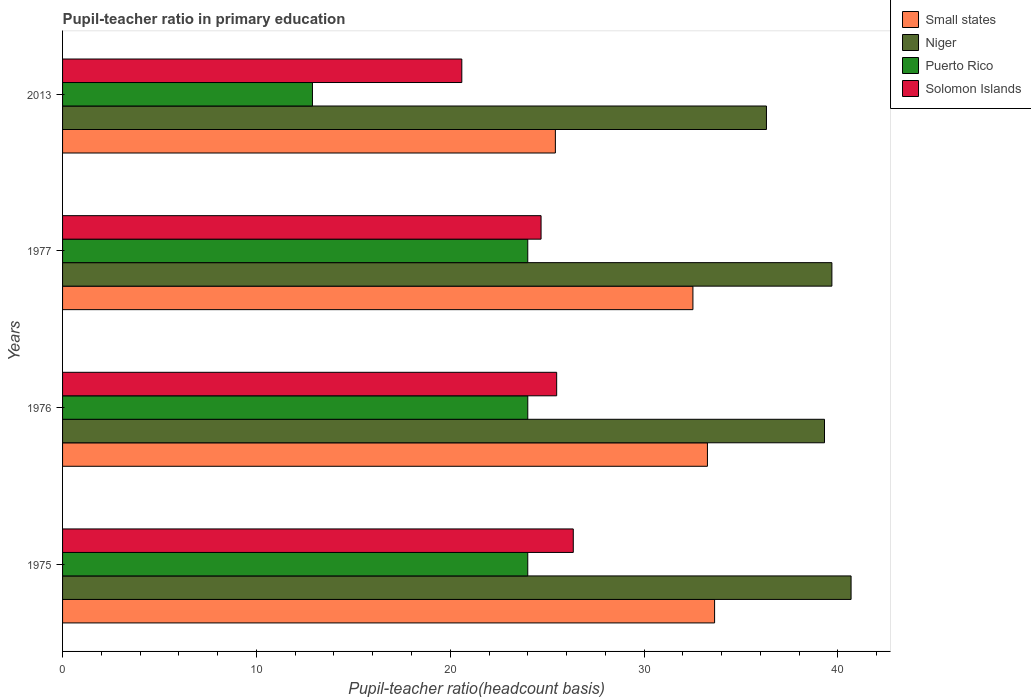What is the label of the 3rd group of bars from the top?
Provide a short and direct response. 1976. What is the pupil-teacher ratio in primary education in Puerto Rico in 1976?
Provide a succinct answer. 24. Across all years, what is the maximum pupil-teacher ratio in primary education in Solomon Islands?
Offer a very short reply. 26.35. Across all years, what is the minimum pupil-teacher ratio in primary education in Puerto Rico?
Offer a very short reply. 12.89. In which year was the pupil-teacher ratio in primary education in Puerto Rico maximum?
Your answer should be very brief. 1976. What is the total pupil-teacher ratio in primary education in Niger in the graph?
Your answer should be compact. 155.99. What is the difference between the pupil-teacher ratio in primary education in Small states in 1975 and that in 2013?
Ensure brevity in your answer.  8.21. What is the difference between the pupil-teacher ratio in primary education in Solomon Islands in 1977 and the pupil-teacher ratio in primary education in Puerto Rico in 1976?
Offer a terse response. 0.69. What is the average pupil-teacher ratio in primary education in Small states per year?
Your response must be concise. 31.21. In the year 2013, what is the difference between the pupil-teacher ratio in primary education in Solomon Islands and pupil-teacher ratio in primary education in Small states?
Make the answer very short. -4.83. What is the ratio of the pupil-teacher ratio in primary education in Niger in 1977 to that in 2013?
Provide a short and direct response. 1.09. Is the pupil-teacher ratio in primary education in Small states in 1975 less than that in 1977?
Ensure brevity in your answer.  No. What is the difference between the highest and the second highest pupil-teacher ratio in primary education in Puerto Rico?
Provide a succinct answer. 0. What is the difference between the highest and the lowest pupil-teacher ratio in primary education in Niger?
Make the answer very short. 4.37. Is the sum of the pupil-teacher ratio in primary education in Puerto Rico in 1976 and 1977 greater than the maximum pupil-teacher ratio in primary education in Small states across all years?
Provide a short and direct response. Yes. Is it the case that in every year, the sum of the pupil-teacher ratio in primary education in Solomon Islands and pupil-teacher ratio in primary education in Niger is greater than the sum of pupil-teacher ratio in primary education in Small states and pupil-teacher ratio in primary education in Puerto Rico?
Provide a short and direct response. No. What does the 2nd bar from the top in 1975 represents?
Provide a succinct answer. Puerto Rico. What does the 1st bar from the bottom in 1975 represents?
Your response must be concise. Small states. How many bars are there?
Provide a short and direct response. 16. How many years are there in the graph?
Offer a very short reply. 4. What is the difference between two consecutive major ticks on the X-axis?
Keep it short and to the point. 10. Are the values on the major ticks of X-axis written in scientific E-notation?
Your answer should be compact. No. Does the graph contain grids?
Your answer should be compact. No. How are the legend labels stacked?
Ensure brevity in your answer.  Vertical. What is the title of the graph?
Give a very brief answer. Pupil-teacher ratio in primary education. What is the label or title of the X-axis?
Provide a short and direct response. Pupil-teacher ratio(headcount basis). What is the label or title of the Y-axis?
Offer a very short reply. Years. What is the Pupil-teacher ratio(headcount basis) of Small states in 1975?
Make the answer very short. 33.64. What is the Pupil-teacher ratio(headcount basis) of Niger in 1975?
Your answer should be very brief. 40.68. What is the Pupil-teacher ratio(headcount basis) of Puerto Rico in 1975?
Your answer should be very brief. 24. What is the Pupil-teacher ratio(headcount basis) of Solomon Islands in 1975?
Offer a terse response. 26.35. What is the Pupil-teacher ratio(headcount basis) in Small states in 1976?
Give a very brief answer. 33.27. What is the Pupil-teacher ratio(headcount basis) of Niger in 1976?
Offer a terse response. 39.31. What is the Pupil-teacher ratio(headcount basis) of Puerto Rico in 1976?
Provide a short and direct response. 24. What is the Pupil-teacher ratio(headcount basis) of Solomon Islands in 1976?
Keep it short and to the point. 25.49. What is the Pupil-teacher ratio(headcount basis) in Small states in 1977?
Make the answer very short. 32.52. What is the Pupil-teacher ratio(headcount basis) of Niger in 1977?
Your response must be concise. 39.69. What is the Pupil-teacher ratio(headcount basis) of Puerto Rico in 1977?
Provide a succinct answer. 24. What is the Pupil-teacher ratio(headcount basis) in Solomon Islands in 1977?
Keep it short and to the point. 24.69. What is the Pupil-teacher ratio(headcount basis) in Small states in 2013?
Provide a succinct answer. 25.42. What is the Pupil-teacher ratio(headcount basis) in Niger in 2013?
Ensure brevity in your answer.  36.31. What is the Pupil-teacher ratio(headcount basis) of Puerto Rico in 2013?
Ensure brevity in your answer.  12.89. What is the Pupil-teacher ratio(headcount basis) in Solomon Islands in 2013?
Your answer should be compact. 20.6. Across all years, what is the maximum Pupil-teacher ratio(headcount basis) in Small states?
Make the answer very short. 33.64. Across all years, what is the maximum Pupil-teacher ratio(headcount basis) of Niger?
Give a very brief answer. 40.68. Across all years, what is the maximum Pupil-teacher ratio(headcount basis) of Puerto Rico?
Your response must be concise. 24. Across all years, what is the maximum Pupil-teacher ratio(headcount basis) in Solomon Islands?
Offer a very short reply. 26.35. Across all years, what is the minimum Pupil-teacher ratio(headcount basis) in Small states?
Make the answer very short. 25.42. Across all years, what is the minimum Pupil-teacher ratio(headcount basis) in Niger?
Your answer should be compact. 36.31. Across all years, what is the minimum Pupil-teacher ratio(headcount basis) in Puerto Rico?
Keep it short and to the point. 12.89. Across all years, what is the minimum Pupil-teacher ratio(headcount basis) of Solomon Islands?
Provide a succinct answer. 20.6. What is the total Pupil-teacher ratio(headcount basis) of Small states in the graph?
Provide a short and direct response. 124.85. What is the total Pupil-teacher ratio(headcount basis) of Niger in the graph?
Your answer should be very brief. 155.99. What is the total Pupil-teacher ratio(headcount basis) in Puerto Rico in the graph?
Keep it short and to the point. 84.89. What is the total Pupil-teacher ratio(headcount basis) of Solomon Islands in the graph?
Give a very brief answer. 97.12. What is the difference between the Pupil-teacher ratio(headcount basis) in Small states in 1975 and that in 1976?
Your answer should be very brief. 0.37. What is the difference between the Pupil-teacher ratio(headcount basis) of Niger in 1975 and that in 1976?
Give a very brief answer. 1.37. What is the difference between the Pupil-teacher ratio(headcount basis) in Puerto Rico in 1975 and that in 1976?
Provide a succinct answer. -0. What is the difference between the Pupil-teacher ratio(headcount basis) in Solomon Islands in 1975 and that in 1976?
Your response must be concise. 0.86. What is the difference between the Pupil-teacher ratio(headcount basis) in Small states in 1975 and that in 1977?
Provide a short and direct response. 1.12. What is the difference between the Pupil-teacher ratio(headcount basis) in Niger in 1975 and that in 1977?
Your response must be concise. 0.99. What is the difference between the Pupil-teacher ratio(headcount basis) in Solomon Islands in 1975 and that in 1977?
Provide a short and direct response. 1.66. What is the difference between the Pupil-teacher ratio(headcount basis) of Small states in 1975 and that in 2013?
Ensure brevity in your answer.  8.21. What is the difference between the Pupil-teacher ratio(headcount basis) of Niger in 1975 and that in 2013?
Your answer should be compact. 4.37. What is the difference between the Pupil-teacher ratio(headcount basis) in Puerto Rico in 1975 and that in 2013?
Offer a very short reply. 11.11. What is the difference between the Pupil-teacher ratio(headcount basis) in Solomon Islands in 1975 and that in 2013?
Give a very brief answer. 5.75. What is the difference between the Pupil-teacher ratio(headcount basis) in Small states in 1976 and that in 1977?
Provide a succinct answer. 0.75. What is the difference between the Pupil-teacher ratio(headcount basis) in Niger in 1976 and that in 1977?
Provide a short and direct response. -0.38. What is the difference between the Pupil-teacher ratio(headcount basis) of Puerto Rico in 1976 and that in 1977?
Provide a succinct answer. 0. What is the difference between the Pupil-teacher ratio(headcount basis) of Solomon Islands in 1976 and that in 1977?
Ensure brevity in your answer.  0.8. What is the difference between the Pupil-teacher ratio(headcount basis) of Small states in 1976 and that in 2013?
Make the answer very short. 7.85. What is the difference between the Pupil-teacher ratio(headcount basis) of Niger in 1976 and that in 2013?
Provide a succinct answer. 2.99. What is the difference between the Pupil-teacher ratio(headcount basis) in Puerto Rico in 1976 and that in 2013?
Provide a succinct answer. 11.11. What is the difference between the Pupil-teacher ratio(headcount basis) in Solomon Islands in 1976 and that in 2013?
Ensure brevity in your answer.  4.89. What is the difference between the Pupil-teacher ratio(headcount basis) of Small states in 1977 and that in 2013?
Ensure brevity in your answer.  7.1. What is the difference between the Pupil-teacher ratio(headcount basis) in Niger in 1977 and that in 2013?
Ensure brevity in your answer.  3.38. What is the difference between the Pupil-teacher ratio(headcount basis) of Puerto Rico in 1977 and that in 2013?
Provide a short and direct response. 11.11. What is the difference between the Pupil-teacher ratio(headcount basis) in Solomon Islands in 1977 and that in 2013?
Your response must be concise. 4.09. What is the difference between the Pupil-teacher ratio(headcount basis) of Small states in 1975 and the Pupil-teacher ratio(headcount basis) of Niger in 1976?
Make the answer very short. -5.67. What is the difference between the Pupil-teacher ratio(headcount basis) in Small states in 1975 and the Pupil-teacher ratio(headcount basis) in Puerto Rico in 1976?
Offer a terse response. 9.64. What is the difference between the Pupil-teacher ratio(headcount basis) in Small states in 1975 and the Pupil-teacher ratio(headcount basis) in Solomon Islands in 1976?
Provide a succinct answer. 8.15. What is the difference between the Pupil-teacher ratio(headcount basis) in Niger in 1975 and the Pupil-teacher ratio(headcount basis) in Puerto Rico in 1976?
Your answer should be very brief. 16.68. What is the difference between the Pupil-teacher ratio(headcount basis) in Niger in 1975 and the Pupil-teacher ratio(headcount basis) in Solomon Islands in 1976?
Your response must be concise. 15.19. What is the difference between the Pupil-teacher ratio(headcount basis) of Puerto Rico in 1975 and the Pupil-teacher ratio(headcount basis) of Solomon Islands in 1976?
Ensure brevity in your answer.  -1.49. What is the difference between the Pupil-teacher ratio(headcount basis) of Small states in 1975 and the Pupil-teacher ratio(headcount basis) of Niger in 1977?
Provide a succinct answer. -6.05. What is the difference between the Pupil-teacher ratio(headcount basis) of Small states in 1975 and the Pupil-teacher ratio(headcount basis) of Puerto Rico in 1977?
Offer a very short reply. 9.64. What is the difference between the Pupil-teacher ratio(headcount basis) in Small states in 1975 and the Pupil-teacher ratio(headcount basis) in Solomon Islands in 1977?
Provide a short and direct response. 8.95. What is the difference between the Pupil-teacher ratio(headcount basis) in Niger in 1975 and the Pupil-teacher ratio(headcount basis) in Puerto Rico in 1977?
Provide a short and direct response. 16.68. What is the difference between the Pupil-teacher ratio(headcount basis) of Niger in 1975 and the Pupil-teacher ratio(headcount basis) of Solomon Islands in 1977?
Offer a very short reply. 15.99. What is the difference between the Pupil-teacher ratio(headcount basis) in Puerto Rico in 1975 and the Pupil-teacher ratio(headcount basis) in Solomon Islands in 1977?
Your answer should be compact. -0.69. What is the difference between the Pupil-teacher ratio(headcount basis) in Small states in 1975 and the Pupil-teacher ratio(headcount basis) in Niger in 2013?
Provide a short and direct response. -2.68. What is the difference between the Pupil-teacher ratio(headcount basis) in Small states in 1975 and the Pupil-teacher ratio(headcount basis) in Puerto Rico in 2013?
Provide a short and direct response. 20.75. What is the difference between the Pupil-teacher ratio(headcount basis) of Small states in 1975 and the Pupil-teacher ratio(headcount basis) of Solomon Islands in 2013?
Your answer should be compact. 13.04. What is the difference between the Pupil-teacher ratio(headcount basis) of Niger in 1975 and the Pupil-teacher ratio(headcount basis) of Puerto Rico in 2013?
Keep it short and to the point. 27.79. What is the difference between the Pupil-teacher ratio(headcount basis) of Niger in 1975 and the Pupil-teacher ratio(headcount basis) of Solomon Islands in 2013?
Provide a succinct answer. 20.08. What is the difference between the Pupil-teacher ratio(headcount basis) of Puerto Rico in 1975 and the Pupil-teacher ratio(headcount basis) of Solomon Islands in 2013?
Ensure brevity in your answer.  3.4. What is the difference between the Pupil-teacher ratio(headcount basis) of Small states in 1976 and the Pupil-teacher ratio(headcount basis) of Niger in 1977?
Give a very brief answer. -6.42. What is the difference between the Pupil-teacher ratio(headcount basis) of Small states in 1976 and the Pupil-teacher ratio(headcount basis) of Puerto Rico in 1977?
Your response must be concise. 9.27. What is the difference between the Pupil-teacher ratio(headcount basis) of Small states in 1976 and the Pupil-teacher ratio(headcount basis) of Solomon Islands in 1977?
Provide a short and direct response. 8.58. What is the difference between the Pupil-teacher ratio(headcount basis) in Niger in 1976 and the Pupil-teacher ratio(headcount basis) in Puerto Rico in 1977?
Give a very brief answer. 15.31. What is the difference between the Pupil-teacher ratio(headcount basis) of Niger in 1976 and the Pupil-teacher ratio(headcount basis) of Solomon Islands in 1977?
Your answer should be very brief. 14.62. What is the difference between the Pupil-teacher ratio(headcount basis) in Puerto Rico in 1976 and the Pupil-teacher ratio(headcount basis) in Solomon Islands in 1977?
Make the answer very short. -0.69. What is the difference between the Pupil-teacher ratio(headcount basis) in Small states in 1976 and the Pupil-teacher ratio(headcount basis) in Niger in 2013?
Your response must be concise. -3.04. What is the difference between the Pupil-teacher ratio(headcount basis) in Small states in 1976 and the Pupil-teacher ratio(headcount basis) in Puerto Rico in 2013?
Your answer should be compact. 20.38. What is the difference between the Pupil-teacher ratio(headcount basis) of Small states in 1976 and the Pupil-teacher ratio(headcount basis) of Solomon Islands in 2013?
Your answer should be very brief. 12.67. What is the difference between the Pupil-teacher ratio(headcount basis) of Niger in 1976 and the Pupil-teacher ratio(headcount basis) of Puerto Rico in 2013?
Your response must be concise. 26.42. What is the difference between the Pupil-teacher ratio(headcount basis) in Niger in 1976 and the Pupil-teacher ratio(headcount basis) in Solomon Islands in 2013?
Provide a succinct answer. 18.71. What is the difference between the Pupil-teacher ratio(headcount basis) in Puerto Rico in 1976 and the Pupil-teacher ratio(headcount basis) in Solomon Islands in 2013?
Provide a short and direct response. 3.4. What is the difference between the Pupil-teacher ratio(headcount basis) of Small states in 1977 and the Pupil-teacher ratio(headcount basis) of Niger in 2013?
Your answer should be compact. -3.79. What is the difference between the Pupil-teacher ratio(headcount basis) of Small states in 1977 and the Pupil-teacher ratio(headcount basis) of Puerto Rico in 2013?
Give a very brief answer. 19.63. What is the difference between the Pupil-teacher ratio(headcount basis) in Small states in 1977 and the Pupil-teacher ratio(headcount basis) in Solomon Islands in 2013?
Make the answer very short. 11.92. What is the difference between the Pupil-teacher ratio(headcount basis) in Niger in 1977 and the Pupil-teacher ratio(headcount basis) in Puerto Rico in 2013?
Your response must be concise. 26.8. What is the difference between the Pupil-teacher ratio(headcount basis) in Niger in 1977 and the Pupil-teacher ratio(headcount basis) in Solomon Islands in 2013?
Ensure brevity in your answer.  19.09. What is the difference between the Pupil-teacher ratio(headcount basis) in Puerto Rico in 1977 and the Pupil-teacher ratio(headcount basis) in Solomon Islands in 2013?
Ensure brevity in your answer.  3.4. What is the average Pupil-teacher ratio(headcount basis) in Small states per year?
Provide a short and direct response. 31.21. What is the average Pupil-teacher ratio(headcount basis) of Niger per year?
Provide a succinct answer. 39. What is the average Pupil-teacher ratio(headcount basis) of Puerto Rico per year?
Ensure brevity in your answer.  21.22. What is the average Pupil-teacher ratio(headcount basis) in Solomon Islands per year?
Provide a short and direct response. 24.28. In the year 1975, what is the difference between the Pupil-teacher ratio(headcount basis) of Small states and Pupil-teacher ratio(headcount basis) of Niger?
Provide a succinct answer. -7.04. In the year 1975, what is the difference between the Pupil-teacher ratio(headcount basis) of Small states and Pupil-teacher ratio(headcount basis) of Puerto Rico?
Offer a very short reply. 9.64. In the year 1975, what is the difference between the Pupil-teacher ratio(headcount basis) in Small states and Pupil-teacher ratio(headcount basis) in Solomon Islands?
Your response must be concise. 7.29. In the year 1975, what is the difference between the Pupil-teacher ratio(headcount basis) in Niger and Pupil-teacher ratio(headcount basis) in Puerto Rico?
Give a very brief answer. 16.68. In the year 1975, what is the difference between the Pupil-teacher ratio(headcount basis) in Niger and Pupil-teacher ratio(headcount basis) in Solomon Islands?
Keep it short and to the point. 14.33. In the year 1975, what is the difference between the Pupil-teacher ratio(headcount basis) in Puerto Rico and Pupil-teacher ratio(headcount basis) in Solomon Islands?
Keep it short and to the point. -2.35. In the year 1976, what is the difference between the Pupil-teacher ratio(headcount basis) of Small states and Pupil-teacher ratio(headcount basis) of Niger?
Your answer should be very brief. -6.04. In the year 1976, what is the difference between the Pupil-teacher ratio(headcount basis) of Small states and Pupil-teacher ratio(headcount basis) of Puerto Rico?
Keep it short and to the point. 9.27. In the year 1976, what is the difference between the Pupil-teacher ratio(headcount basis) in Small states and Pupil-teacher ratio(headcount basis) in Solomon Islands?
Offer a terse response. 7.78. In the year 1976, what is the difference between the Pupil-teacher ratio(headcount basis) of Niger and Pupil-teacher ratio(headcount basis) of Puerto Rico?
Keep it short and to the point. 15.31. In the year 1976, what is the difference between the Pupil-teacher ratio(headcount basis) of Niger and Pupil-teacher ratio(headcount basis) of Solomon Islands?
Your response must be concise. 13.82. In the year 1976, what is the difference between the Pupil-teacher ratio(headcount basis) in Puerto Rico and Pupil-teacher ratio(headcount basis) in Solomon Islands?
Offer a very short reply. -1.49. In the year 1977, what is the difference between the Pupil-teacher ratio(headcount basis) of Small states and Pupil-teacher ratio(headcount basis) of Niger?
Provide a short and direct response. -7.17. In the year 1977, what is the difference between the Pupil-teacher ratio(headcount basis) of Small states and Pupil-teacher ratio(headcount basis) of Puerto Rico?
Offer a terse response. 8.52. In the year 1977, what is the difference between the Pupil-teacher ratio(headcount basis) in Small states and Pupil-teacher ratio(headcount basis) in Solomon Islands?
Ensure brevity in your answer.  7.83. In the year 1977, what is the difference between the Pupil-teacher ratio(headcount basis) of Niger and Pupil-teacher ratio(headcount basis) of Puerto Rico?
Offer a very short reply. 15.69. In the year 1977, what is the difference between the Pupil-teacher ratio(headcount basis) in Niger and Pupil-teacher ratio(headcount basis) in Solomon Islands?
Offer a terse response. 15. In the year 1977, what is the difference between the Pupil-teacher ratio(headcount basis) of Puerto Rico and Pupil-teacher ratio(headcount basis) of Solomon Islands?
Give a very brief answer. -0.69. In the year 2013, what is the difference between the Pupil-teacher ratio(headcount basis) of Small states and Pupil-teacher ratio(headcount basis) of Niger?
Make the answer very short. -10.89. In the year 2013, what is the difference between the Pupil-teacher ratio(headcount basis) of Small states and Pupil-teacher ratio(headcount basis) of Puerto Rico?
Your response must be concise. 12.53. In the year 2013, what is the difference between the Pupil-teacher ratio(headcount basis) in Small states and Pupil-teacher ratio(headcount basis) in Solomon Islands?
Your answer should be compact. 4.83. In the year 2013, what is the difference between the Pupil-teacher ratio(headcount basis) in Niger and Pupil-teacher ratio(headcount basis) in Puerto Rico?
Offer a terse response. 23.42. In the year 2013, what is the difference between the Pupil-teacher ratio(headcount basis) of Niger and Pupil-teacher ratio(headcount basis) of Solomon Islands?
Offer a terse response. 15.72. In the year 2013, what is the difference between the Pupil-teacher ratio(headcount basis) of Puerto Rico and Pupil-teacher ratio(headcount basis) of Solomon Islands?
Offer a terse response. -7.71. What is the ratio of the Pupil-teacher ratio(headcount basis) of Small states in 1975 to that in 1976?
Your response must be concise. 1.01. What is the ratio of the Pupil-teacher ratio(headcount basis) of Niger in 1975 to that in 1976?
Give a very brief answer. 1.03. What is the ratio of the Pupil-teacher ratio(headcount basis) of Solomon Islands in 1975 to that in 1976?
Your answer should be compact. 1.03. What is the ratio of the Pupil-teacher ratio(headcount basis) in Small states in 1975 to that in 1977?
Keep it short and to the point. 1.03. What is the ratio of the Pupil-teacher ratio(headcount basis) in Puerto Rico in 1975 to that in 1977?
Your answer should be very brief. 1. What is the ratio of the Pupil-teacher ratio(headcount basis) of Solomon Islands in 1975 to that in 1977?
Provide a succinct answer. 1.07. What is the ratio of the Pupil-teacher ratio(headcount basis) in Small states in 1975 to that in 2013?
Make the answer very short. 1.32. What is the ratio of the Pupil-teacher ratio(headcount basis) of Niger in 1975 to that in 2013?
Offer a very short reply. 1.12. What is the ratio of the Pupil-teacher ratio(headcount basis) of Puerto Rico in 1975 to that in 2013?
Your answer should be very brief. 1.86. What is the ratio of the Pupil-teacher ratio(headcount basis) of Solomon Islands in 1975 to that in 2013?
Your response must be concise. 1.28. What is the ratio of the Pupil-teacher ratio(headcount basis) in Small states in 1976 to that in 1977?
Your response must be concise. 1.02. What is the ratio of the Pupil-teacher ratio(headcount basis) of Puerto Rico in 1976 to that in 1977?
Provide a short and direct response. 1. What is the ratio of the Pupil-teacher ratio(headcount basis) in Solomon Islands in 1976 to that in 1977?
Provide a succinct answer. 1.03. What is the ratio of the Pupil-teacher ratio(headcount basis) in Small states in 1976 to that in 2013?
Keep it short and to the point. 1.31. What is the ratio of the Pupil-teacher ratio(headcount basis) of Niger in 1976 to that in 2013?
Your answer should be compact. 1.08. What is the ratio of the Pupil-teacher ratio(headcount basis) in Puerto Rico in 1976 to that in 2013?
Give a very brief answer. 1.86. What is the ratio of the Pupil-teacher ratio(headcount basis) of Solomon Islands in 1976 to that in 2013?
Your response must be concise. 1.24. What is the ratio of the Pupil-teacher ratio(headcount basis) of Small states in 1977 to that in 2013?
Ensure brevity in your answer.  1.28. What is the ratio of the Pupil-teacher ratio(headcount basis) in Niger in 1977 to that in 2013?
Make the answer very short. 1.09. What is the ratio of the Pupil-teacher ratio(headcount basis) in Puerto Rico in 1977 to that in 2013?
Ensure brevity in your answer.  1.86. What is the ratio of the Pupil-teacher ratio(headcount basis) of Solomon Islands in 1977 to that in 2013?
Offer a very short reply. 1.2. What is the difference between the highest and the second highest Pupil-teacher ratio(headcount basis) in Small states?
Give a very brief answer. 0.37. What is the difference between the highest and the second highest Pupil-teacher ratio(headcount basis) of Niger?
Keep it short and to the point. 0.99. What is the difference between the highest and the second highest Pupil-teacher ratio(headcount basis) of Puerto Rico?
Make the answer very short. 0. What is the difference between the highest and the second highest Pupil-teacher ratio(headcount basis) in Solomon Islands?
Your answer should be very brief. 0.86. What is the difference between the highest and the lowest Pupil-teacher ratio(headcount basis) in Small states?
Your response must be concise. 8.21. What is the difference between the highest and the lowest Pupil-teacher ratio(headcount basis) in Niger?
Your answer should be very brief. 4.37. What is the difference between the highest and the lowest Pupil-teacher ratio(headcount basis) of Puerto Rico?
Ensure brevity in your answer.  11.11. What is the difference between the highest and the lowest Pupil-teacher ratio(headcount basis) of Solomon Islands?
Your response must be concise. 5.75. 